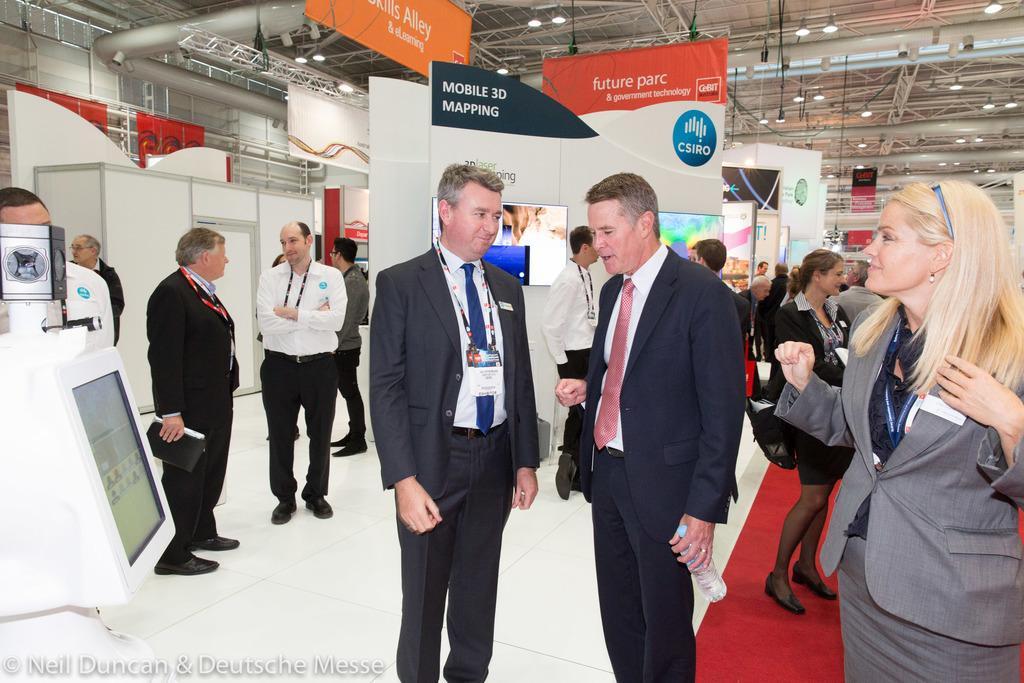Please provide a concise description of this image. In this image there are people standing on a floor, on the left side there is a monitor, in the background there are some monitors above that there is some text, at the top there are rods and a roof, in the bottom left there is text. 